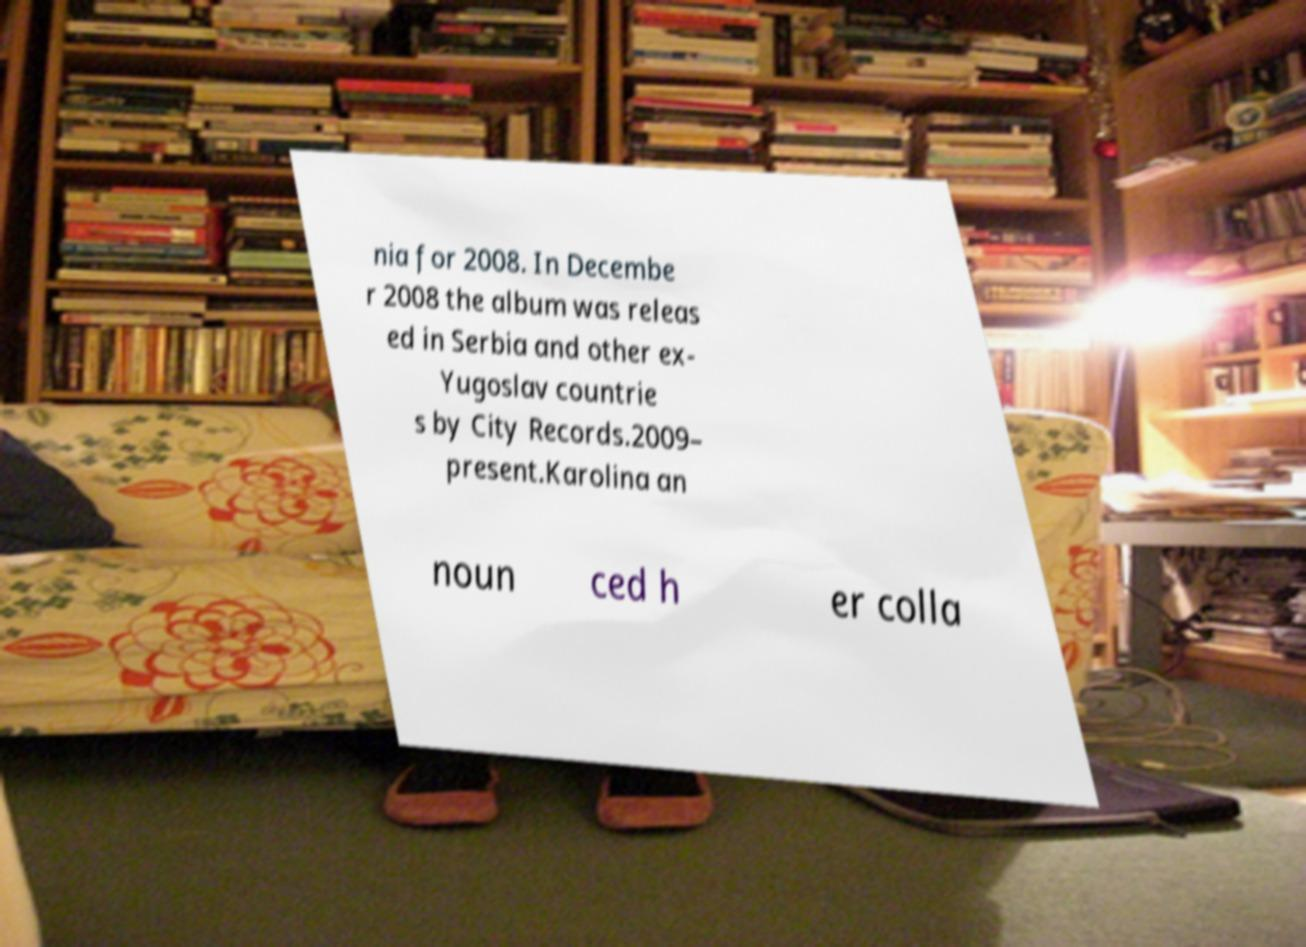For documentation purposes, I need the text within this image transcribed. Could you provide that? nia for 2008. In Decembe r 2008 the album was releas ed in Serbia and other ex- Yugoslav countrie s by City Records.2009– present.Karolina an noun ced h er colla 